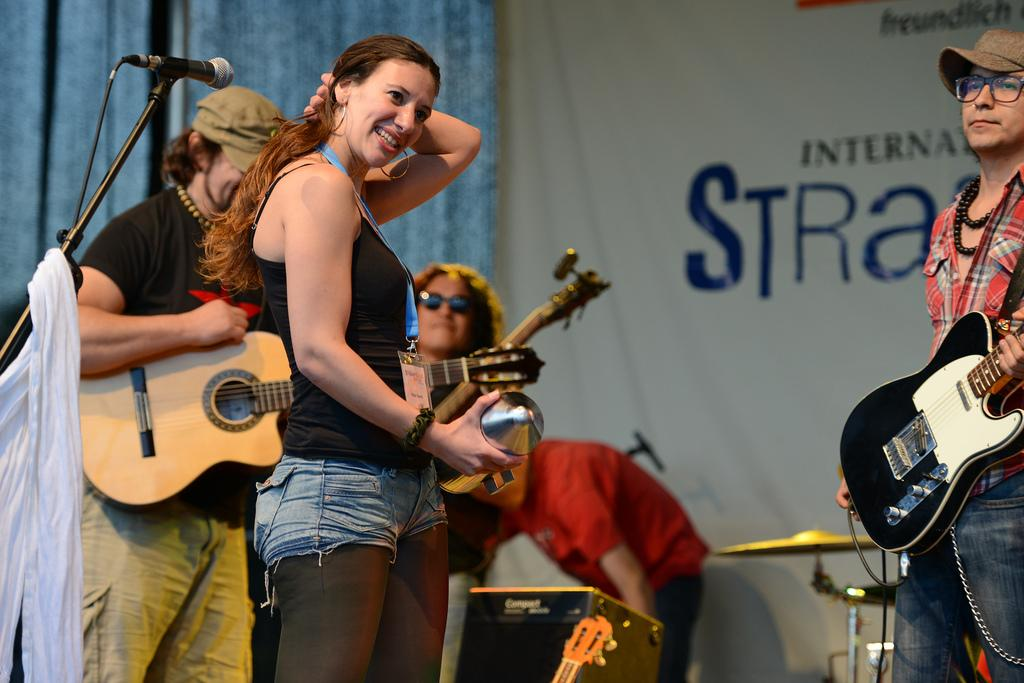How many people are in the group in the image? There is a group of people in the image, but the exact number is not specified. What are the people in the group doing? Each person in the group is holding a musical instrument. What additional equipment is visible in the image? There is a microphone (mic) visible in the image. How many ducks are visible in the image? There are no ducks present in the image. What type of knot is being used to hold the microphone in place? There is no knot visible in the image, as the microphone is not being held in place by any visible means. 